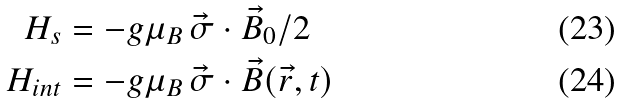Convert formula to latex. <formula><loc_0><loc_0><loc_500><loc_500>H _ { s } & = - g \mu _ { B } \, \vec { \sigma } \cdot \vec { B } _ { 0 } / 2 \\ H _ { i n t } & = - g \mu _ { B } \, \vec { \sigma } \cdot \vec { B } ( \vec { r } , t )</formula> 